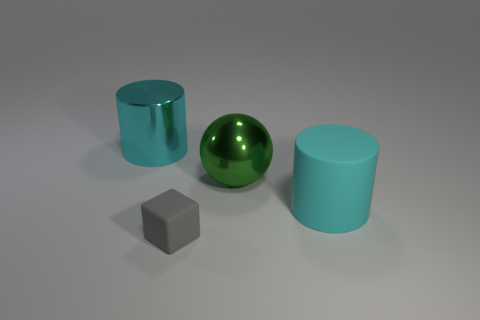Add 2 tiny purple metal cylinders. How many objects exist? 6 Subtract all cubes. How many objects are left? 3 Add 1 green things. How many green things are left? 2 Add 3 big cyan cylinders. How many big cyan cylinders exist? 5 Subtract 0 blue balls. How many objects are left? 4 Subtract all gray matte things. Subtract all large cylinders. How many objects are left? 1 